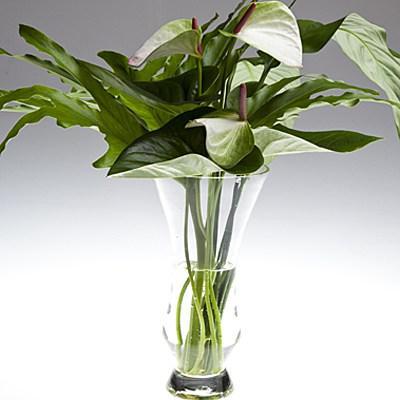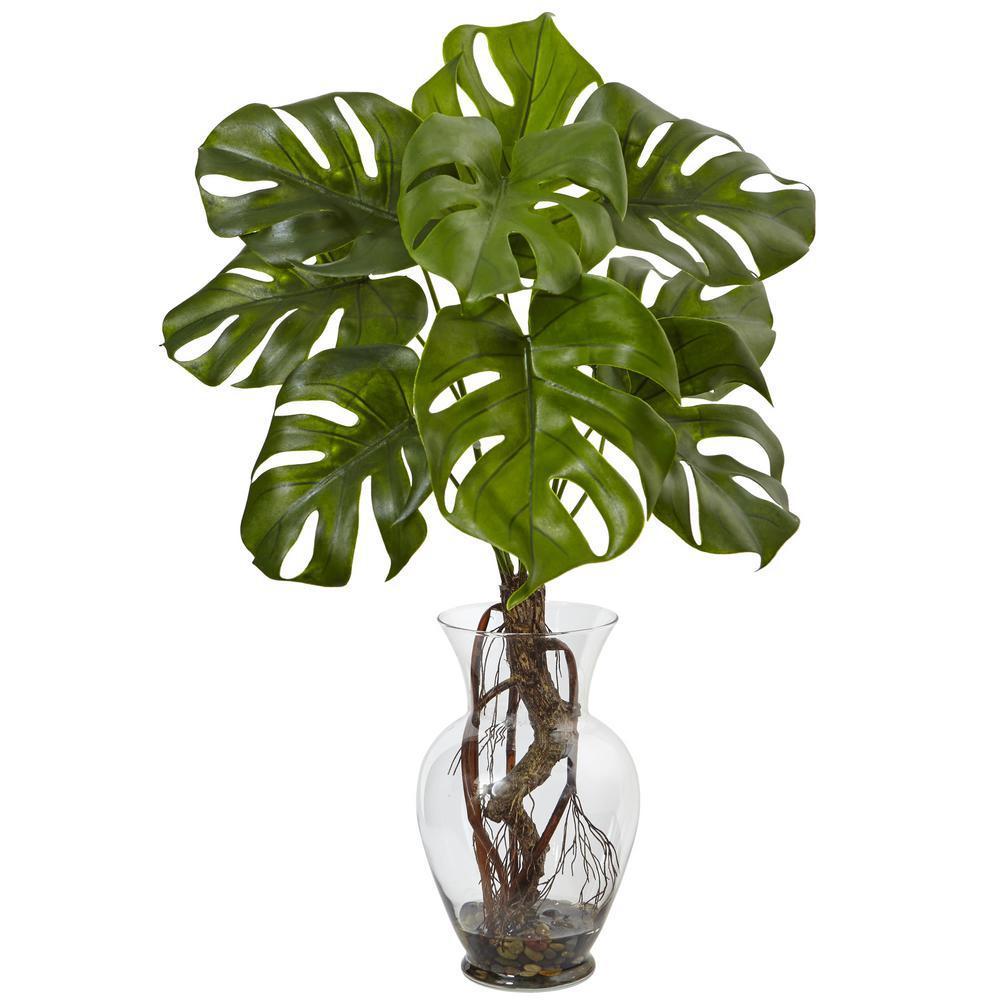The first image is the image on the left, the second image is the image on the right. For the images displayed, is the sentence "One vase is tall, opaque and solid-colored with a ribbed surface, and the other vase is shorter and black in color." factually correct? Answer yes or no. No. The first image is the image on the left, the second image is the image on the right. Analyze the images presented: Is the assertion "At least one vase is clear glass." valid? Answer yes or no. Yes. 